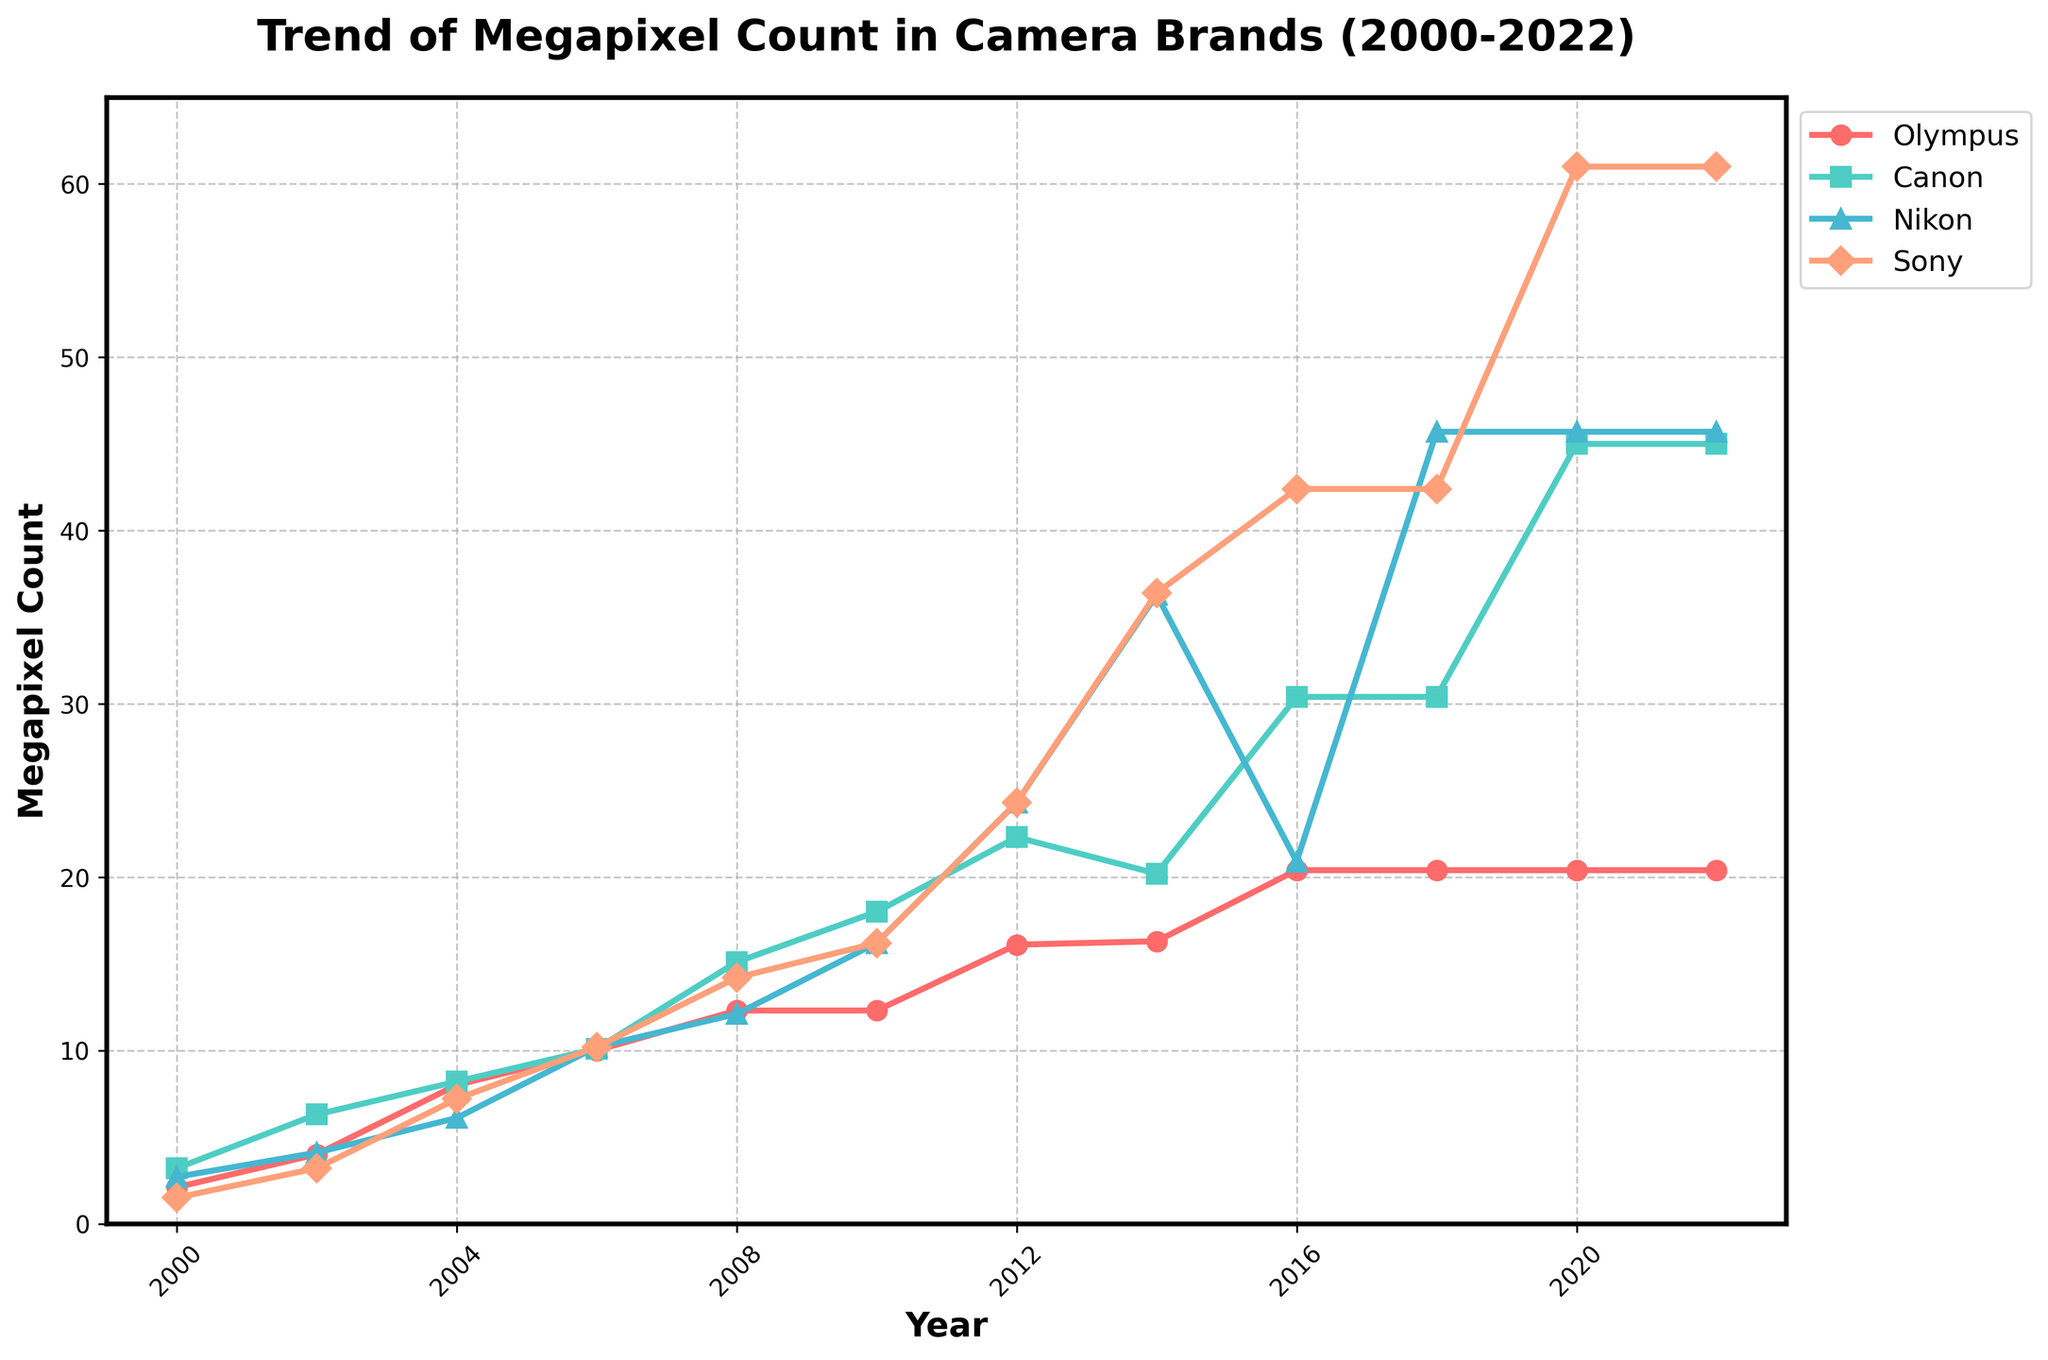What is the trend in megapixel count for Olympus cameras from 2000 to 2022? By examining the Olympus line in the figure, we see a general upward trend from 2.1 megapixels in 2000 to 20.4 megapixels in 2022. Around 2010, the increase starts to stabilize, maintaining 20.4 megapixels from 2016 onwards.
Answer: Upward trend until 2022 How does the megapixel count of Olympus cameras in 2022 compare to Sony cameras in the same year? In 2022, Olympus cameras have a megapixel count of 20.4, while Sony cameras have a significantly higher count of 61.0.
Answer: Sony Which brand has the highest megapixel count in 2022? The top line of the figure in 2022 represents Sony, which exceeds other brands with a maximum megapixel count of 61.0.
Answer: Sony What year did Nikon cameras surpass Olympus cameras in megapixel count? Nikon cameras surpass Olympus cameras in megapixel count in 2012 when Nikon reaches 24.3 megapixels compared to Olympus's 16.1 megapixels.
Answer: 2012 By how much did Sony's megapixel count increase from 2000 to 2022? Sony's megapixel count increased from 1.5 in 2000 to 61.0 in 2022, resulting in an increase of 59.5 megapixels.
Answer: 59.5 Which year saw the highest increase in megapixel count for Canon cameras? The highest increase for Canon cameras occurs between 2010 (18.0) and 2012 (22.3), with an increase of 4.3 megapixels.
Answer: Between 2010 and 2012 Did Olympus cameras ever have the highest megapixel count among the brands listed? The Olympus line never surpasses other brands in any given year. For instance, from 2002 onwards, Canon exceeds Olympus, and by 2008, other brands like Nikon and Sony have also surpassed Olympus.
Answer: No What is the difference in Sony’s megapixel count between 2018 and 2022? In 2018, Sony's megapixel count was 42.4, and it increased to 61.0 by 2022, resulting in a difference of 18.6 megapixels.
Answer: 18.6 On average, how many megapixels do Canon cameras gain every two years from 2000 to 2022? Canon starts at 3.2 (2000) and ends at 45.0 (2022). Over 22 years (11 intervals), Canon's average gain every two years is (45.0 - 3.2) / 11 = 3.8 megapixels per interval (2 years).
Answer: 3.8 Which two brands have nearly the same megapixel count in 2014, and what is the approximate count? In 2014, Nikon and Sony have nearly the same megapixel counts, with Nikon at 36.3 and Sony at 36.4.
Answer: Nikon and Sony, ~36.4 